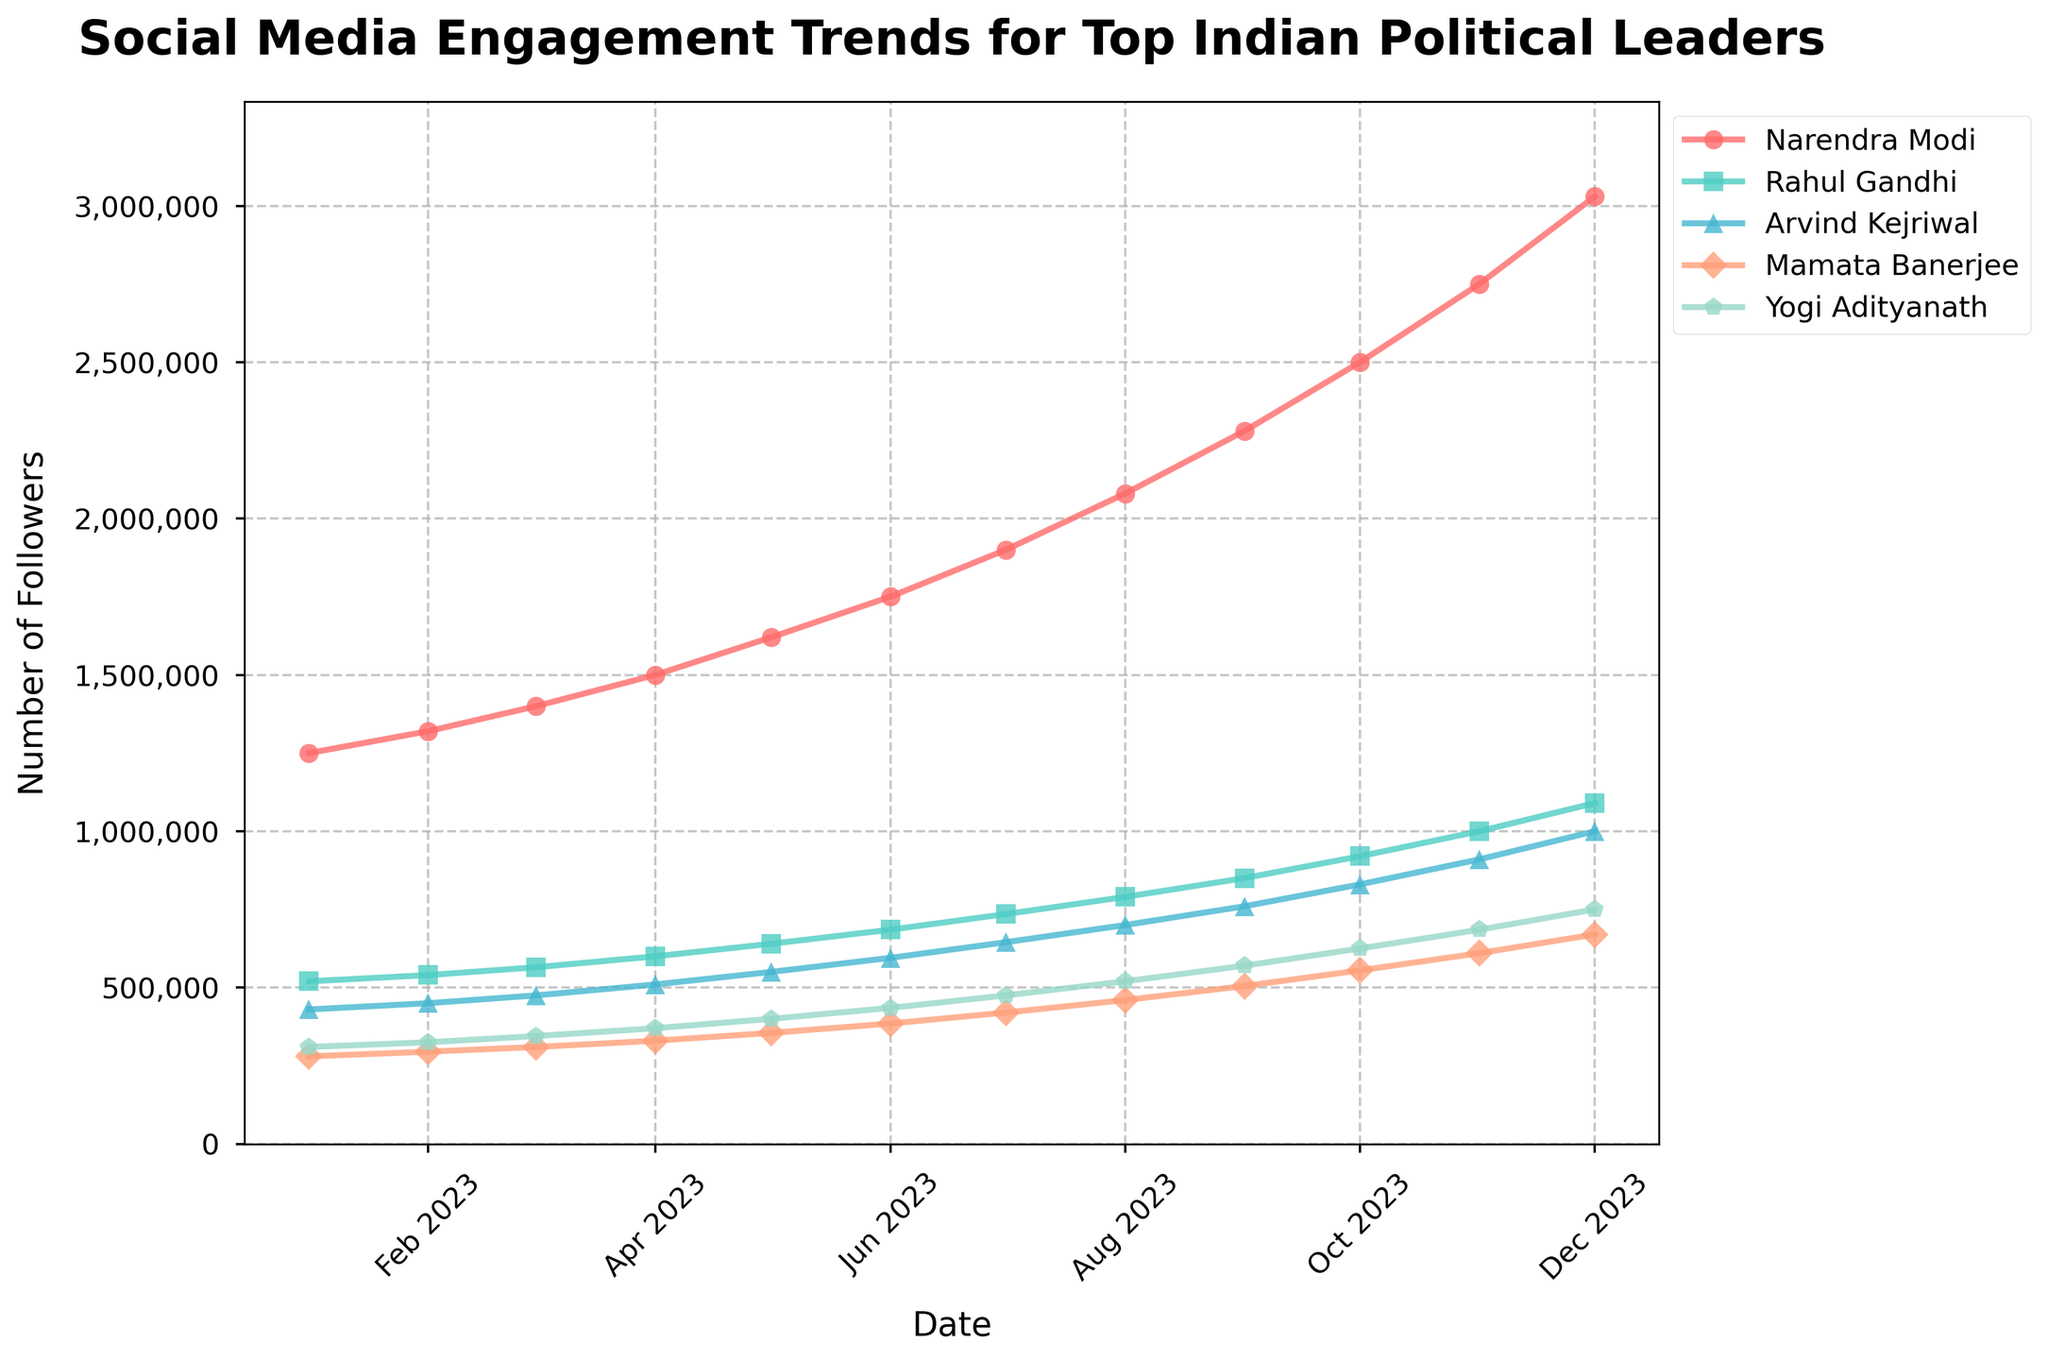What is the overall trend in social media engagement for Narendra Modi from January 2023 to December 2023? The line representing Narendra Modi’s follower count consistently increases month after month, indicating a positive trend in social media engagement. The number of followers starts at 1,250,000 in January 2023 and ends at 3,030,000 in December 2023.
Answer: Positive trend Between which two months did Rahul Gandhi see the highest increase in followers? To find the highest increase, we need to calculate the difference between each consecutive month for Rahul Gandhi. The biggest increase is between December 2023 (1,090,000 followers) and November 2023 (1,000,000 followers), with a difference of 90,000 followers.
Answer: November 2023 - December 2023 Who had the least social media engagement in December 2023, and what was the number of followers? To determine this, we check the follower numbers for December 2023 for all leaders. Mamata Banerjee has the lowest count with 670,000 followers.
Answer: Mamata Banerjee, 670,000 followers Which month did Arvind Kejriwal reach 700,000 followers? By examining the line representing Arvind Kejriwal, we find that he reached 700,000 followers in August 2023.
Answer: August 2023 How much did Yogi Adityanath’s follower count grow from June 2023 to October 2023? Yogi Adityanath had 435,000 followers in June 2023 and 625,000 in October 2023. The growth is 625,000 - 435,000 = 190,000 followers.
Answer: 190,000 followers Which leader had the highest social media engagement in July 2023, and how many followers did they have? In July 2023, Narendra Modi had the highest engagement with 1,900,000 followers.
Answer: Narendra Modi, 1,900,000 followers How many leaders had more than 1,000,000 followers by December 2023? By December 2023, three leaders surpassed 1,000,000 followers: Narendra Modi, Rahul Gandhi, and Arvind Kejriwal.
Answer: Three leaders Compare the follower growth of Mamata Banerjee and Yogi Adityanath from July 2023 to December 2023. Who had greater growth? Mamata Banerjee had 420,000 followers in July 2023 and 670,000 in December 2023. The growth is 670,000 - 420,000 = 250,000. Yogi Adityanath had 475,000 followers in July 2023 and 750,000 in December 2023. The growth is 750,000 - 475,000 = 275,000. Yogi Adityanath had greater growth.
Answer: Yogi Adityanath What was the average increase in followers per month for Narendra Modi over the year? Narendra Modi's follower count increased from 1,250,000 in January to 3,030,000 in December. The total increase is 3,030,000 - 1,250,000 = 1,780,000. Dividing this by the 11 months from January to December, the average increase per month is 1,780,000 / 11 ≈ 161,818 followers per month.
Answer: Approximately 161,818 followers per month 